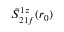<formula> <loc_0><loc_0><loc_500><loc_500>\tilde { S } _ { 2 1 f } ^ { 1 z } ( r _ { 0 } )</formula> 